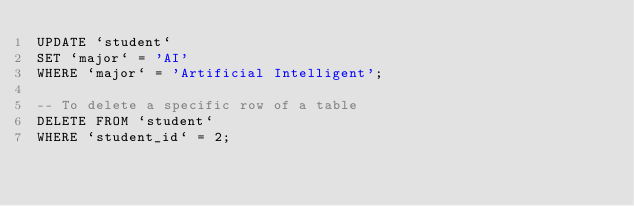Convert code to text. <code><loc_0><loc_0><loc_500><loc_500><_SQL_>UPDATE `student` 
SET `major` = 'AI'
WHERE `major` = 'Artificial Intelligent';

-- To delete a specific row of a table
DELETE FROM `student` 
WHERE `student_id` = 2;</code> 